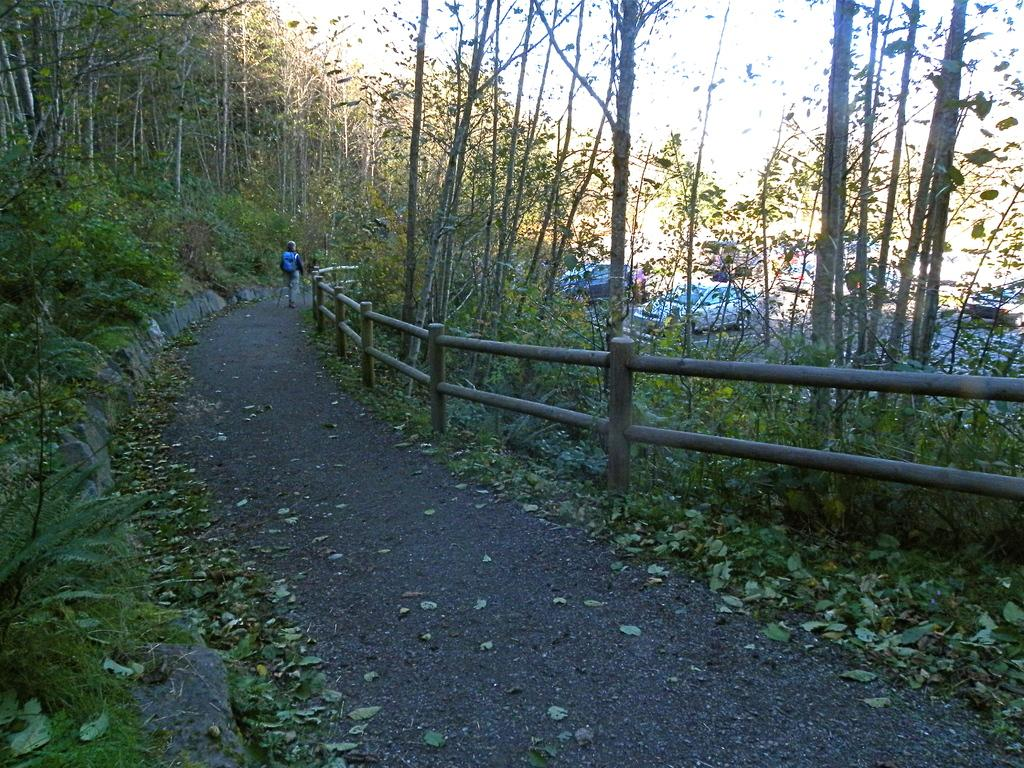What is the person in the image doing? There is a person standing on the road in the image. What can be seen on both sides of the road? There are trees on both sides of the road. What else can be seen on the road? There are cars parked on the road. What type of coal can be seen in the image? There is no coal present in the image. Can you see a rabbit hopping on the road in the image? There is no rabbit present in the image. 